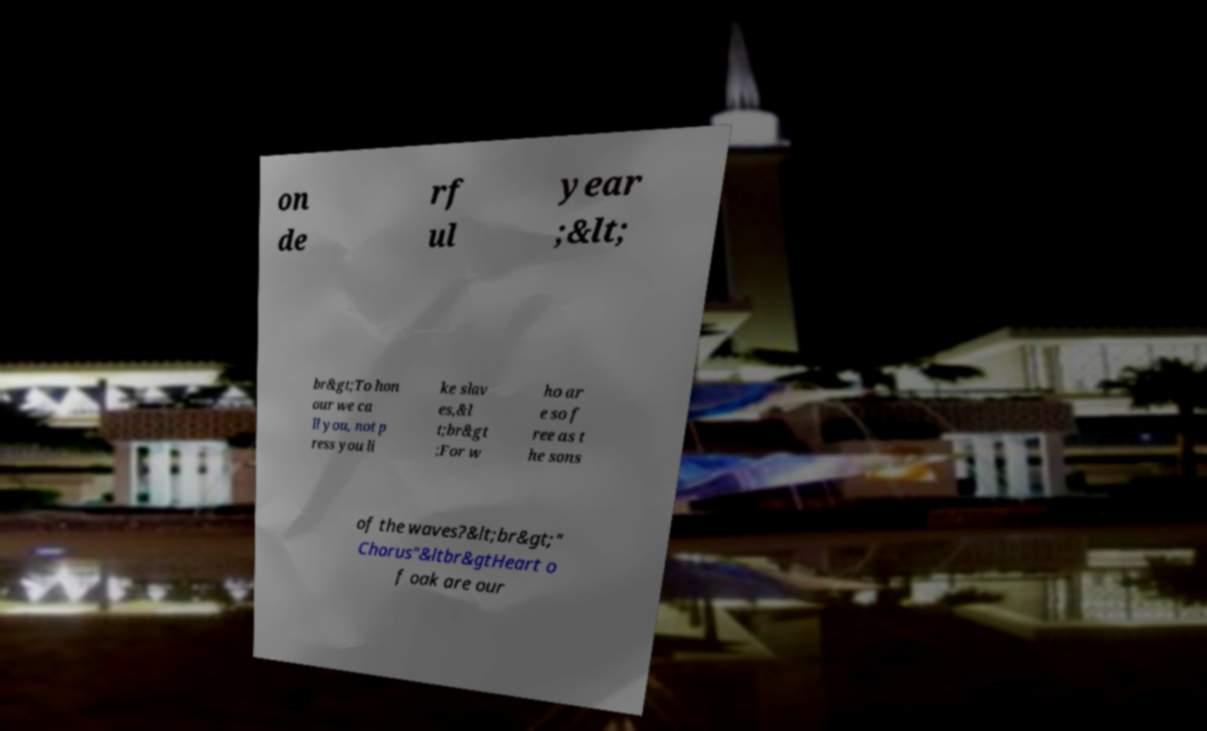For documentation purposes, I need the text within this image transcribed. Could you provide that? on de rf ul year ;&lt; br&gt;To hon our we ca ll you, not p ress you li ke slav es,&l t;br&gt ;For w ho ar e so f ree as t he sons of the waves?&lt;br&gt;" Chorus"&ltbr&gtHeart o f oak are our 